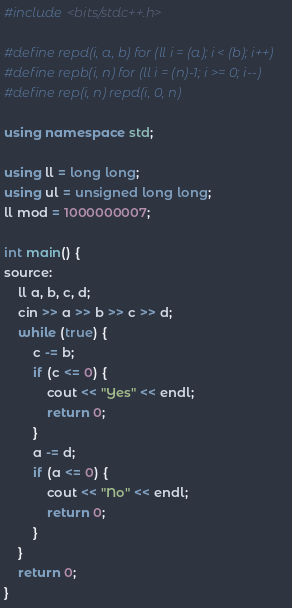<code> <loc_0><loc_0><loc_500><loc_500><_C++_>#include <bits/stdc++.h>

#define repd(i, a, b) for (ll i = (a); i < (b); i++)
#define repb(i, n) for (ll i = (n)-1; i >= 0; i--)
#define rep(i, n) repd(i, 0, n)

using namespace std;

using ll = long long;
using ul = unsigned long long;
ll mod = 1000000007;

int main() {
source:
    ll a, b, c, d;
    cin >> a >> b >> c >> d;
    while (true) {
        c -= b;
        if (c <= 0) {
            cout << "Yes" << endl;
            return 0;
        }
        a -= d;
        if (a <= 0) {
            cout << "No" << endl;
            return 0;
        }
    }
    return 0;
}

</code> 